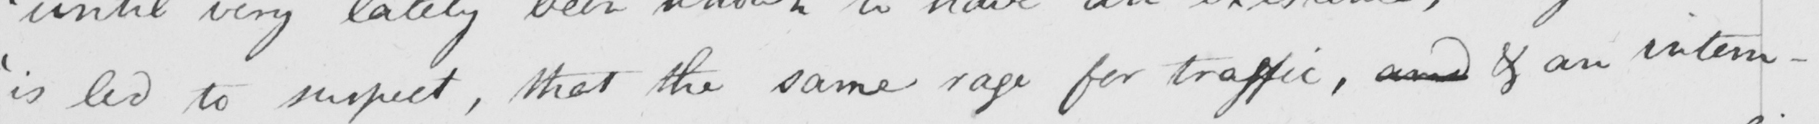Please provide the text content of this handwritten line. ' is led to suspect , that the same rage for traffic , and & an intem- 